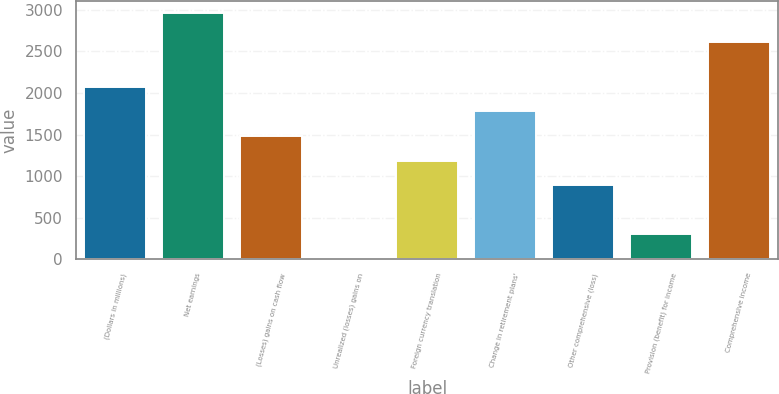Convert chart. <chart><loc_0><loc_0><loc_500><loc_500><bar_chart><fcel>(Dollars in millions)<fcel>Net earnings<fcel>(Losses) gains on cash flow<fcel>Unrealized (losses) gains on<fcel>Foreign currency translation<fcel>Change in retirement plans'<fcel>Other comprehensive (loss)<fcel>Provision (benefit) for income<fcel>Comprehensive income<nl><fcel>2076.1<fcel>2965<fcel>1483.5<fcel>2<fcel>1187.2<fcel>1779.8<fcel>890.9<fcel>298.3<fcel>2611<nl></chart> 